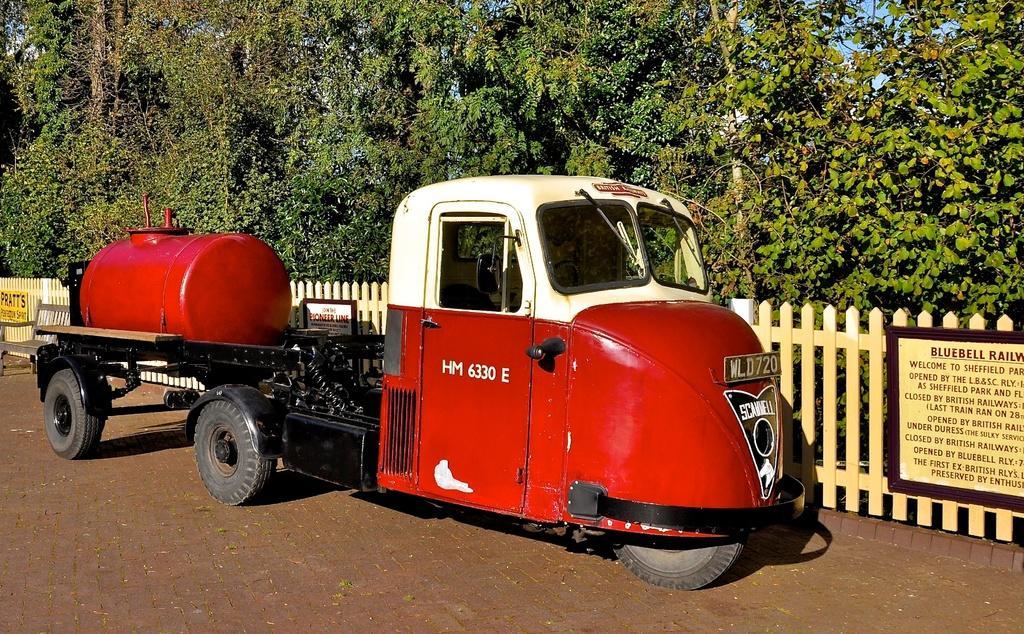In one or two sentences, can you explain what this image depicts? In this image I can see the vehicle in white and red color. In the background I can see the fencing, few boards, trees in green color and the sky is in blue color. 